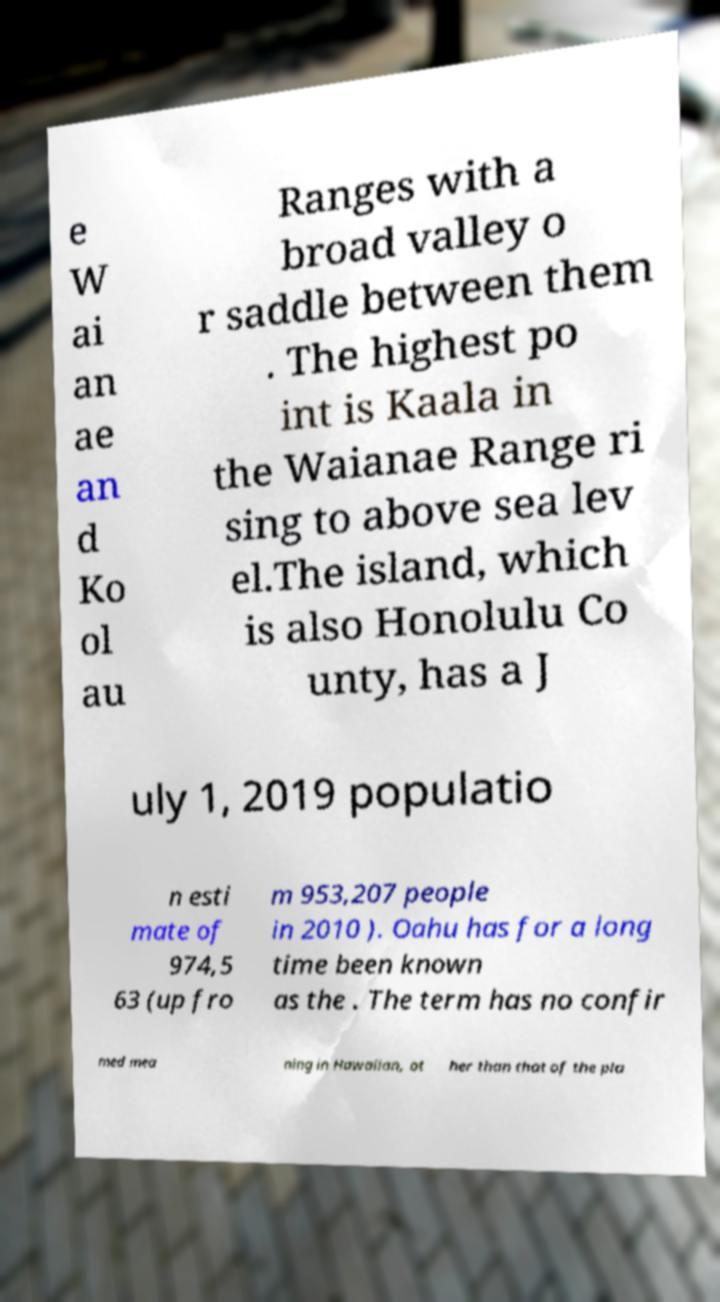There's text embedded in this image that I need extracted. Can you transcribe it verbatim? e W ai an ae an d Ko ol au Ranges with a broad valley o r saddle between them . The highest po int is Kaala in the Waianae Range ri sing to above sea lev el.The island, which is also Honolulu Co unty, has a J uly 1, 2019 populatio n esti mate of 974,5 63 (up fro m 953,207 people in 2010 ). Oahu has for a long time been known as the . The term has no confir med mea ning in Hawaiian, ot her than that of the pla 